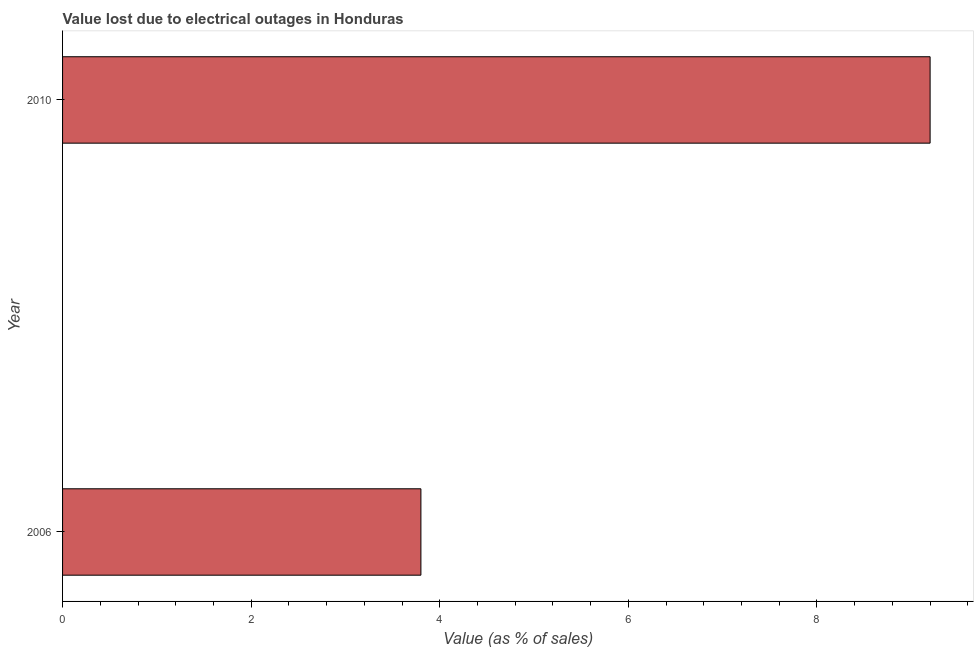Does the graph contain any zero values?
Offer a very short reply. No. What is the title of the graph?
Your response must be concise. Value lost due to electrical outages in Honduras. What is the label or title of the X-axis?
Your response must be concise. Value (as % of sales). Across all years, what is the maximum value lost due to electrical outages?
Provide a short and direct response. 9.2. In which year was the value lost due to electrical outages maximum?
Keep it short and to the point. 2010. What is the sum of the value lost due to electrical outages?
Offer a very short reply. 13. What is the average value lost due to electrical outages per year?
Provide a succinct answer. 6.5. In how many years, is the value lost due to electrical outages greater than 4.8 %?
Make the answer very short. 1. Do a majority of the years between 2006 and 2010 (inclusive) have value lost due to electrical outages greater than 7.6 %?
Provide a succinct answer. No. What is the ratio of the value lost due to electrical outages in 2006 to that in 2010?
Give a very brief answer. 0.41. Is the value lost due to electrical outages in 2006 less than that in 2010?
Ensure brevity in your answer.  Yes. How many bars are there?
Make the answer very short. 2. Are the values on the major ticks of X-axis written in scientific E-notation?
Offer a terse response. No. What is the Value (as % of sales) of 2006?
Provide a short and direct response. 3.8. What is the ratio of the Value (as % of sales) in 2006 to that in 2010?
Keep it short and to the point. 0.41. 